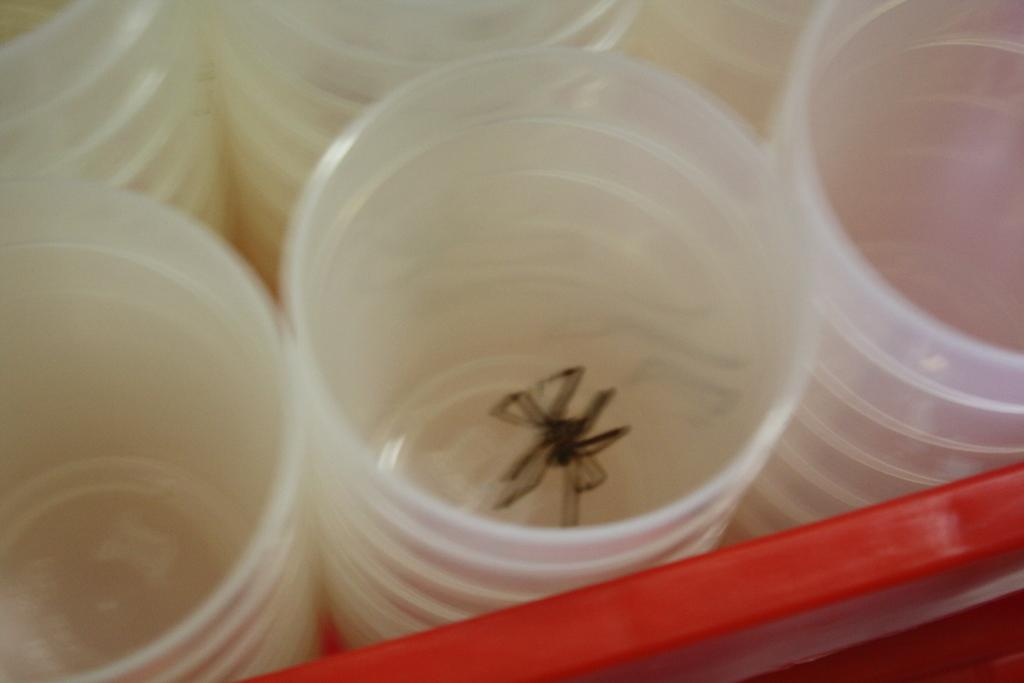What type of glasses are visible in the image? There are plastic glasses in the image. What is inside one of the glasses? There is a spider in one of the glasses. Where is the father sitting in the image? There is no father present in the image; it only features plastic glasses and a spider. How many fish can be seen swimming in the glasses? There are no fish present in the image; it only features plastic glasses and a spider. 